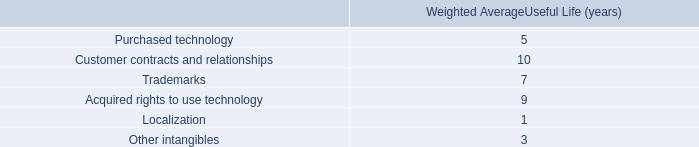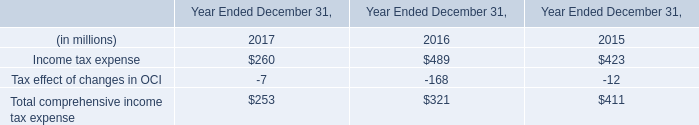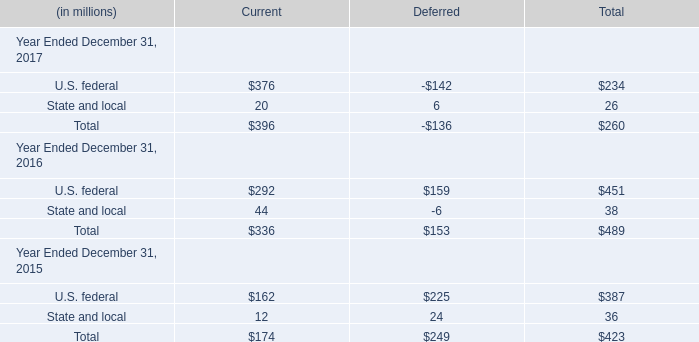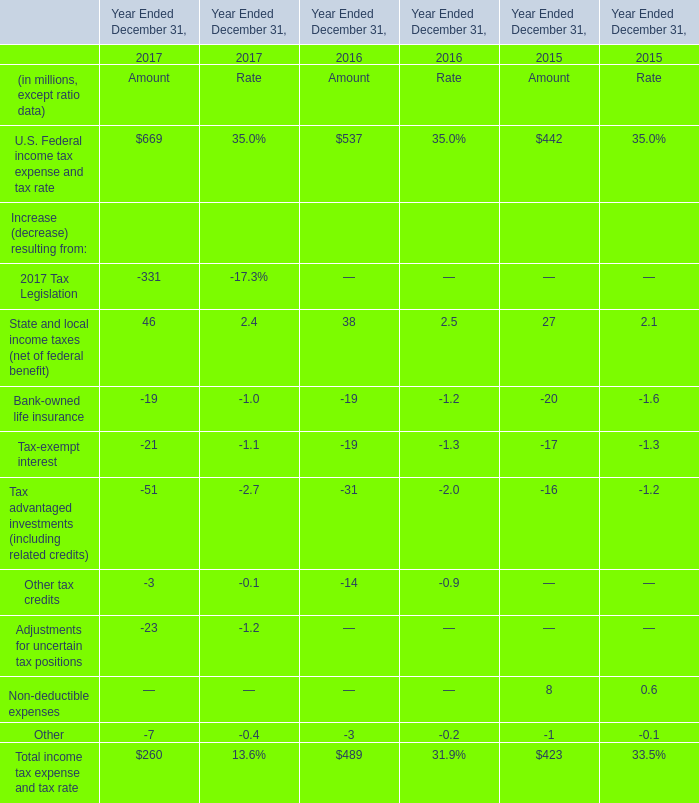Which year is State and local for Current the lowest? 
Answer: 2017. 